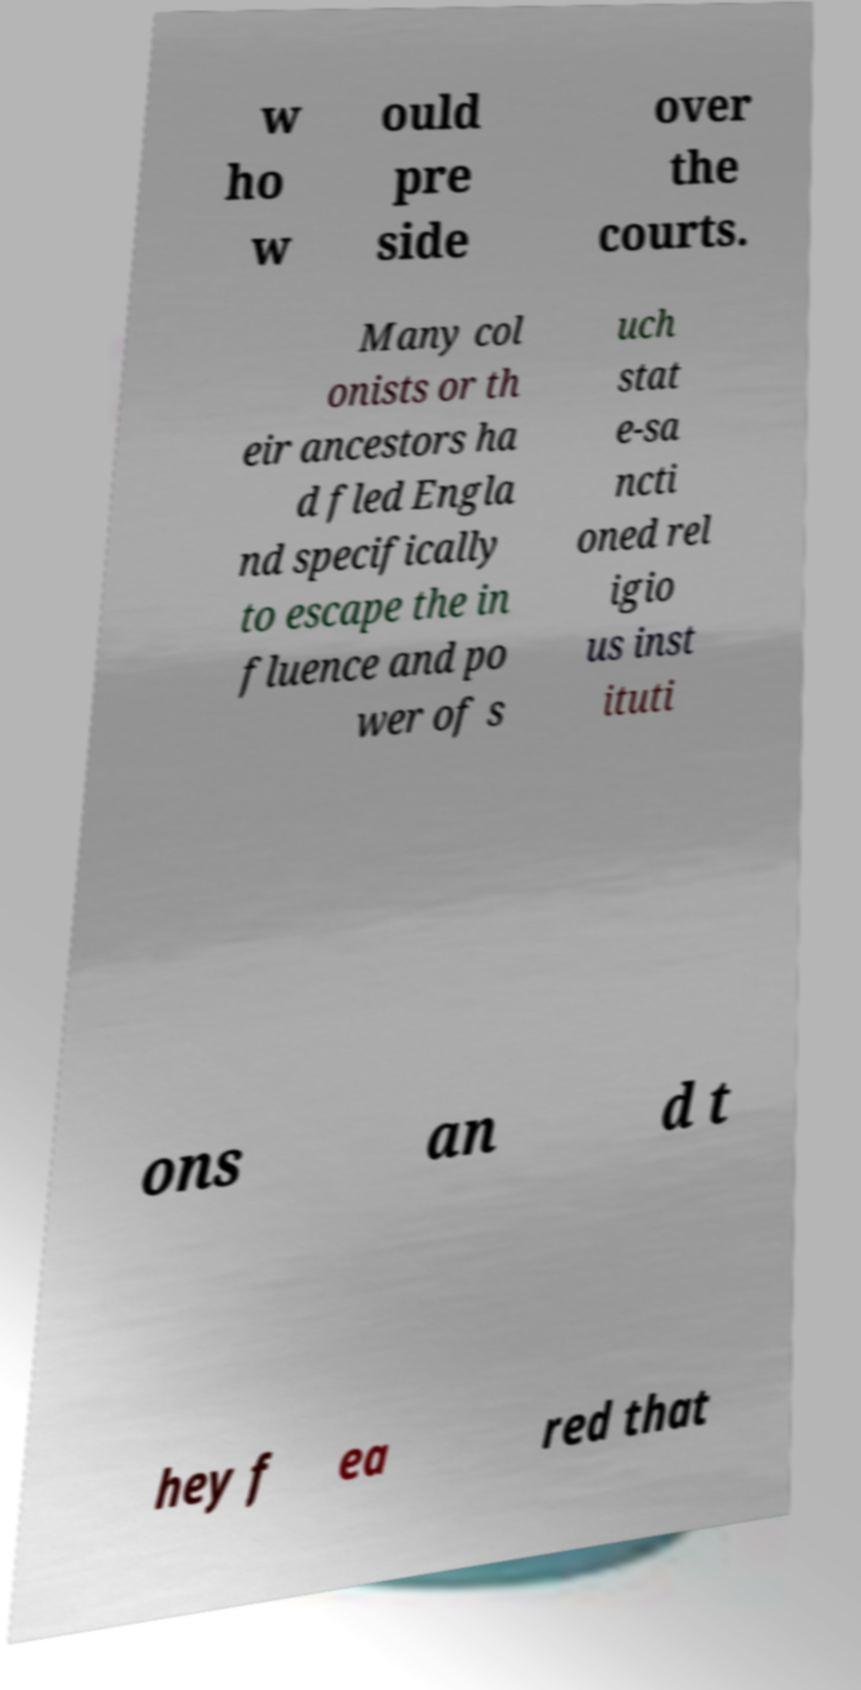I need the written content from this picture converted into text. Can you do that? w ho w ould pre side over the courts. Many col onists or th eir ancestors ha d fled Engla nd specifically to escape the in fluence and po wer of s uch stat e-sa ncti oned rel igio us inst ituti ons an d t hey f ea red that 